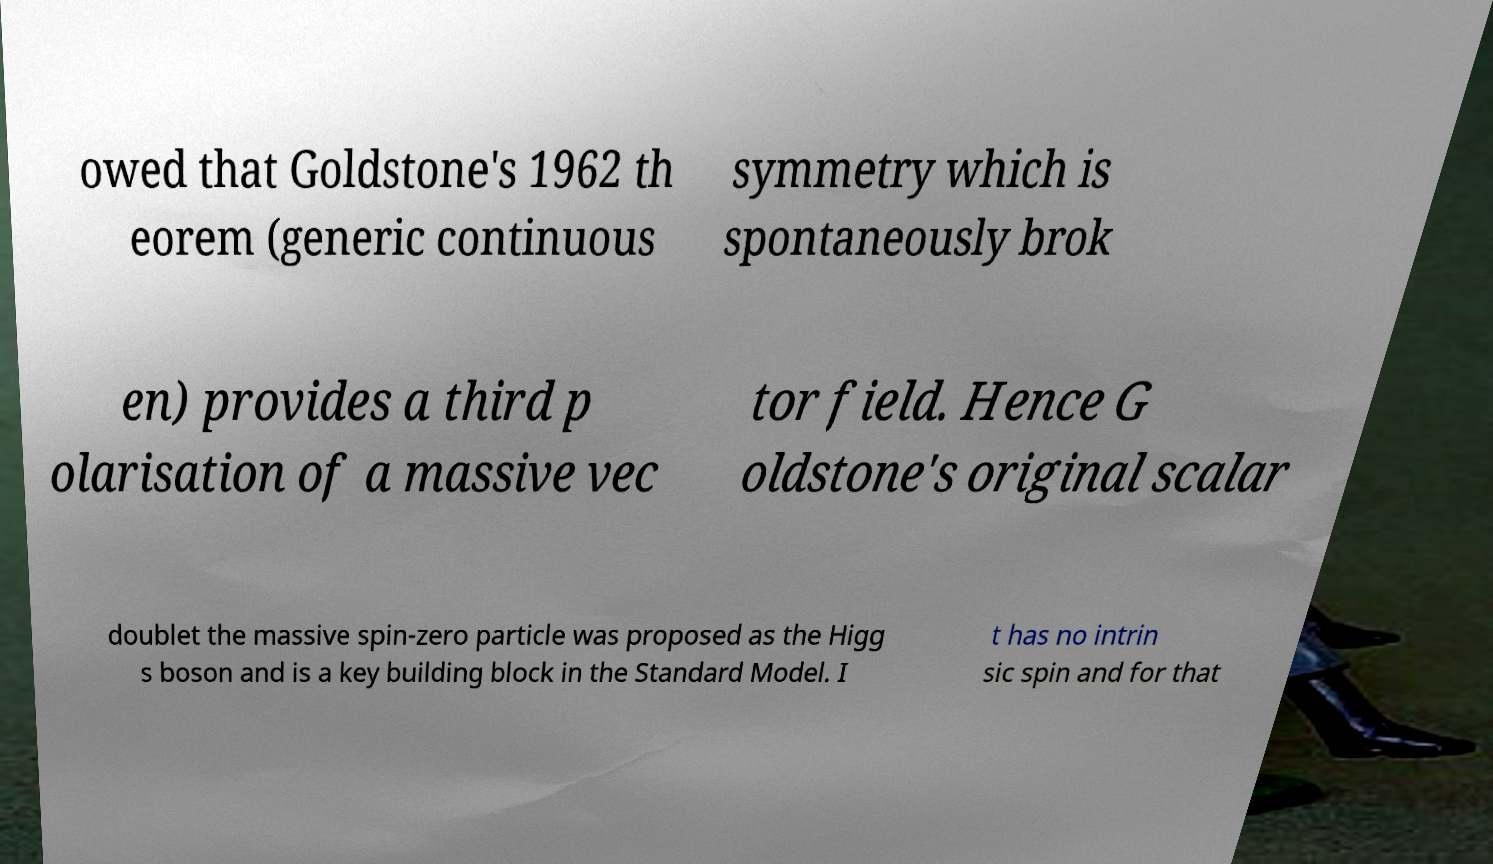Please read and relay the text visible in this image. What does it say? owed that Goldstone's 1962 th eorem (generic continuous symmetry which is spontaneously brok en) provides a third p olarisation of a massive vec tor field. Hence G oldstone's original scalar doublet the massive spin-zero particle was proposed as the Higg s boson and is a key building block in the Standard Model. I t has no intrin sic spin and for that 